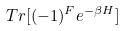<formula> <loc_0><loc_0><loc_500><loc_500>T r [ ( - 1 ) ^ { F } e ^ { - \beta H } ]</formula> 